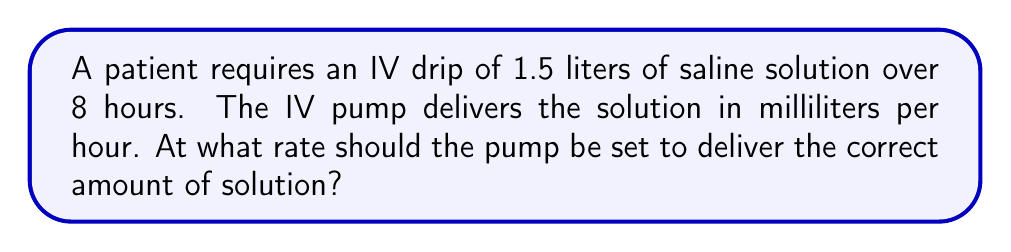What is the answer to this math problem? To solve this problem, we need to convert the volume from liters to milliliters and calculate the rate per hour. Let's break it down step-by-step:

1. Convert 1.5 liters to milliliters:
   $1.5 \text{ L} \times 1000 \text{ mL/L} = 1500 \text{ mL}$

2. Set up the equation to find the rate per hour:
   $\text{Rate} = \frac{\text{Total volume}}{\text{Total time}}$

3. Plug in the values:
   $\text{Rate} = \frac{1500 \text{ mL}}{8 \text{ hours}}$

4. Perform the division:
   $\text{Rate} = 187.5 \text{ mL/hour}$

Therefore, the IV pump should be set to deliver 187.5 milliliters per hour.
Answer: 187.5 mL/hour 